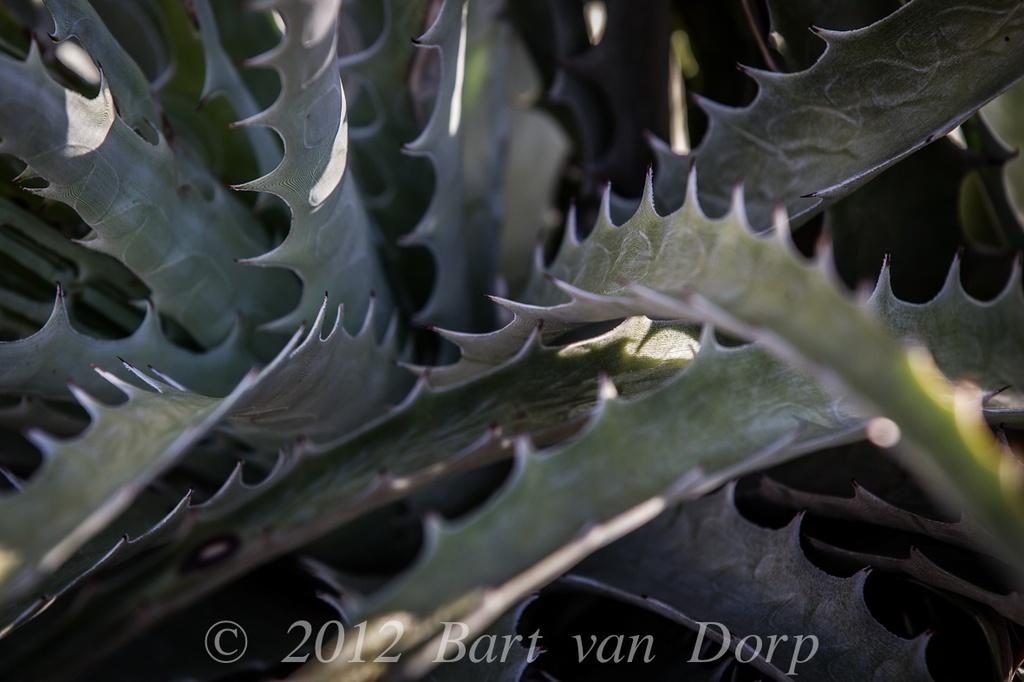What is present in the image? There is a plant in the image. Can you describe the plant's features? The plant has leaves, and the leaves have thorns. Is there any additional information about the image? Yes, there is a watermark at the bottom of the image. What type of soap is being used to clean the plant in the image? There is no soap or cleaning activity present in the image; it only features a plant with thorny leaves. 